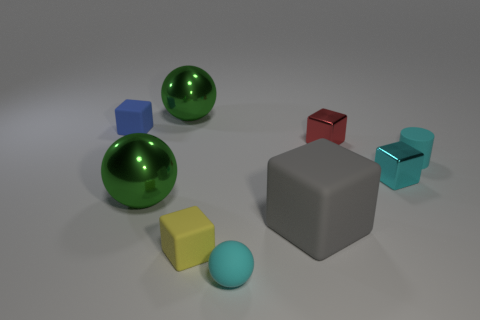How many matte things are large gray objects or tiny cylinders? In the image, there is one large matte gray cube which fits the criteria of being a large gray object. There are no tiny cylinders visible. So, in total, there is just one item that matches the description provided in the question. 